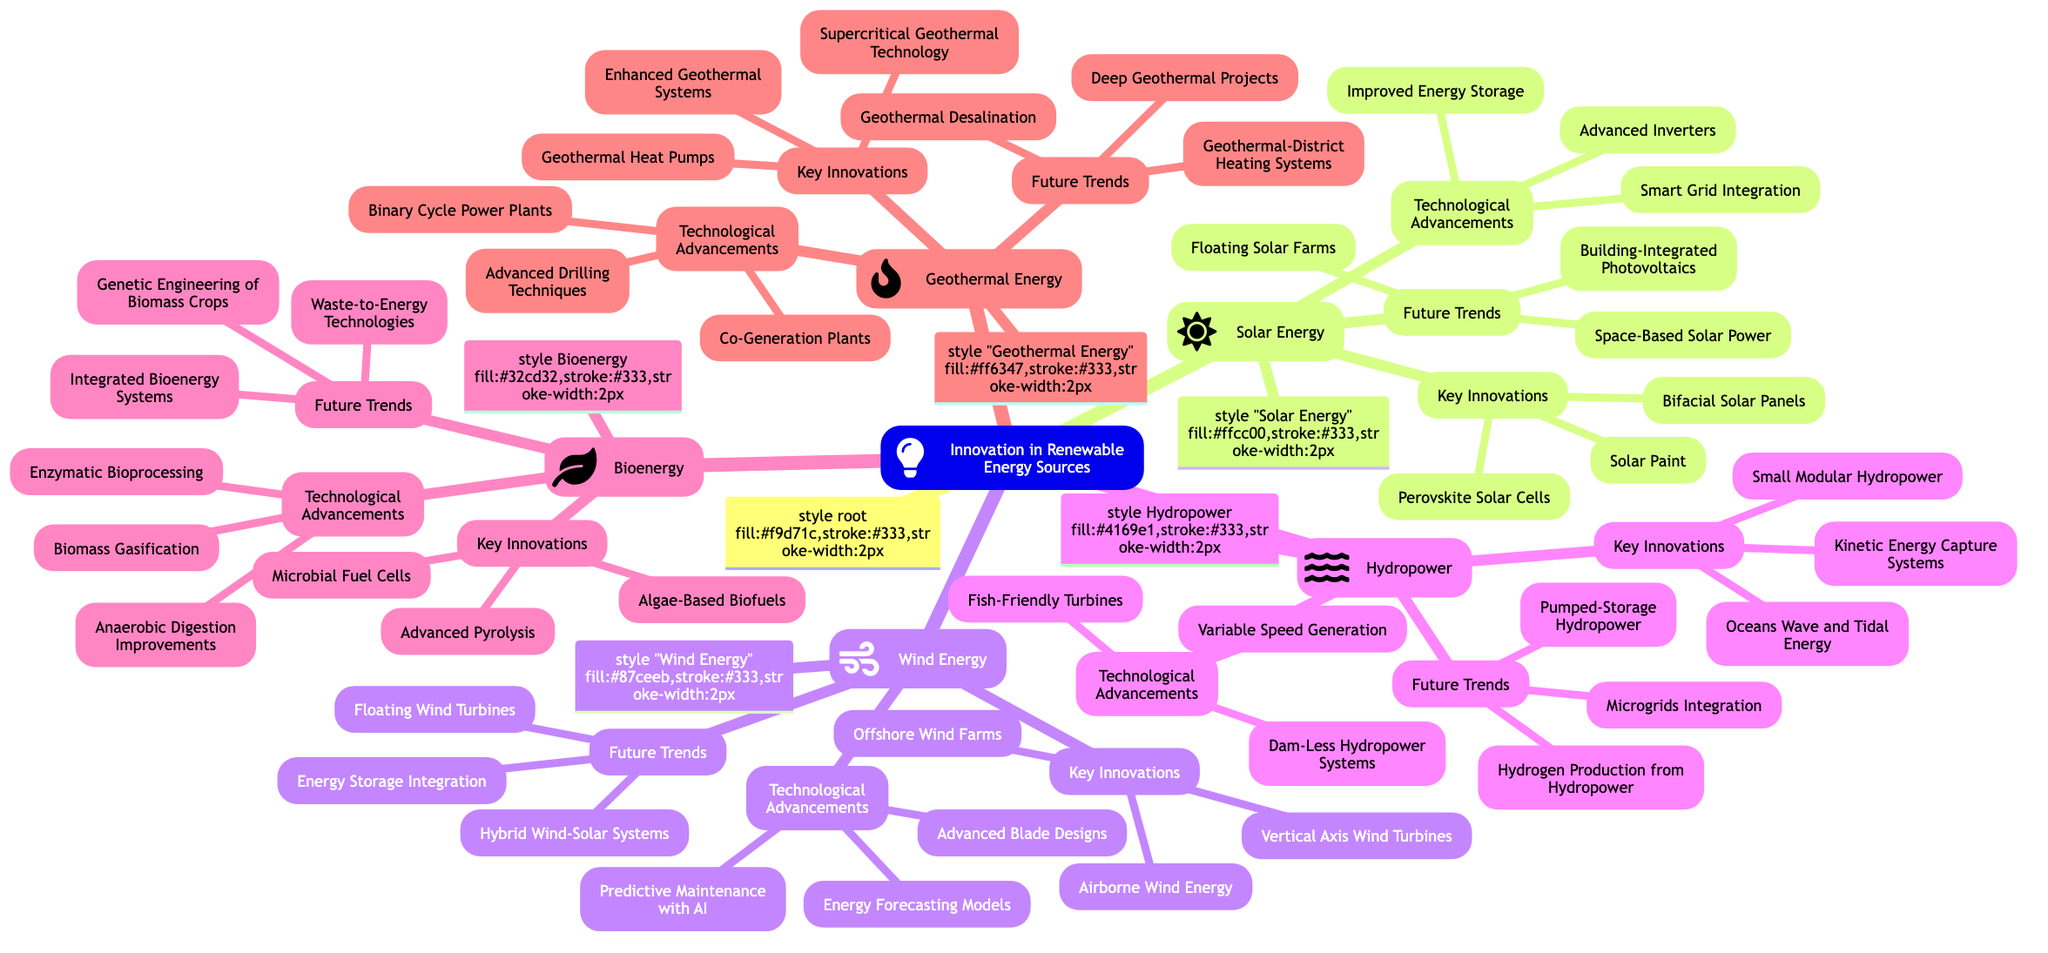What are the key innovations in Solar Energy? The subtopic "Key Innovations" under "Solar Energy" lists three items: "Perovskite Solar Cells," "Bifacial Solar Panels," and "Solar Paint."
Answer: Perovskite Solar Cells, Bifacial Solar Panels, Solar Paint How many technological advancements are listed under Wind Energy? The "Technological Advancements" node for "Wind Energy" has three innovations: "Advanced Blade Designs," "Predictive Maintenance with AI," and "Energy Forecasting Models." This indicates there are three advancements.
Answer: 3 What is one future trend noted for Hydropower? The "Future Trends" section for "Hydropower" includes three potential trends: "Microgrids Integration," "Hydrogen Production from Hydropower," and "Pumped-Storage Hydropower." One example is "Microgrids Integration."
Answer: Microgrids Integration Which energy source includes "Floating Wind Turbines" as a future trend? "Floating Wind Turbines" appears under the "Future Trends" section categorized under "Wind Energy," differentiating it from other energy sources.
Answer: Wind Energy Describe the relationship between Bioenergy's key innovations and technological advancements. "Bioenergy" has both "Key Innovations" and "Technological Advancements" listed. Specific innovations include "Algae-Based Biofuels," "Advanced Pyrolysis," and "Microbial Fuel Cells," while advancements include "Biomass Gasification," "Anaerobic Digestion Improvements," and "Enzymatic Bioprocessing." The relationship shows how innovations lead to advancements.
Answer: Innovations lead to advancements What are the key innovations for Geothermal Energy? The section "Key Innovations" under "Geothermal Energy" lists: "Enhanced Geothermal Systems," "Supercritical Geothermal Technology," and "Geothermal Heat Pumps," which are essential innovations in this category.
Answer: Enhanced Geothermal Systems, Supercritical Geothermal Technology, Geothermal Heat Pumps How many total main subtopics are present in the diagram? The main topic "Innovation in Renewable Energy Sources" branches into five subtopics: "Solar Energy," "Wind Energy," "Hydropower," "Bioenergy," and "Geothermal Energy." Therefore, there are five main subtopics.
Answer: 5 What distinguishes "Space-Based Solar Power" from other future trends in Solar Energy? "Space-Based Solar Power" is unique among future trends in "Solar Energy" because it involves harnessing solar power from space, unlike more terrestrial concepts like "Building-Integrated Photovoltaics" and "Floating Solar Farms."
Answer: Space-Based Solar Power Identify a future trend for Wind Energy that involves integration with other technologies. "Hybrid Wind-Solar Systems" is a future trend for Wind Energy that indicates a combination of wind technology with solar energy systems, showcasing technology integration.
Answer: Hybrid Wind-Solar Systems What innovation is associated with fish safety in Hydropower? The technological advancement "Fish-Friendly Turbines" focuses on making hydropower systems safer for aquatic life, marking it as a notable innovation related to ecological considerations in Hydropower systems.
Answer: Fish-Friendly Turbines 